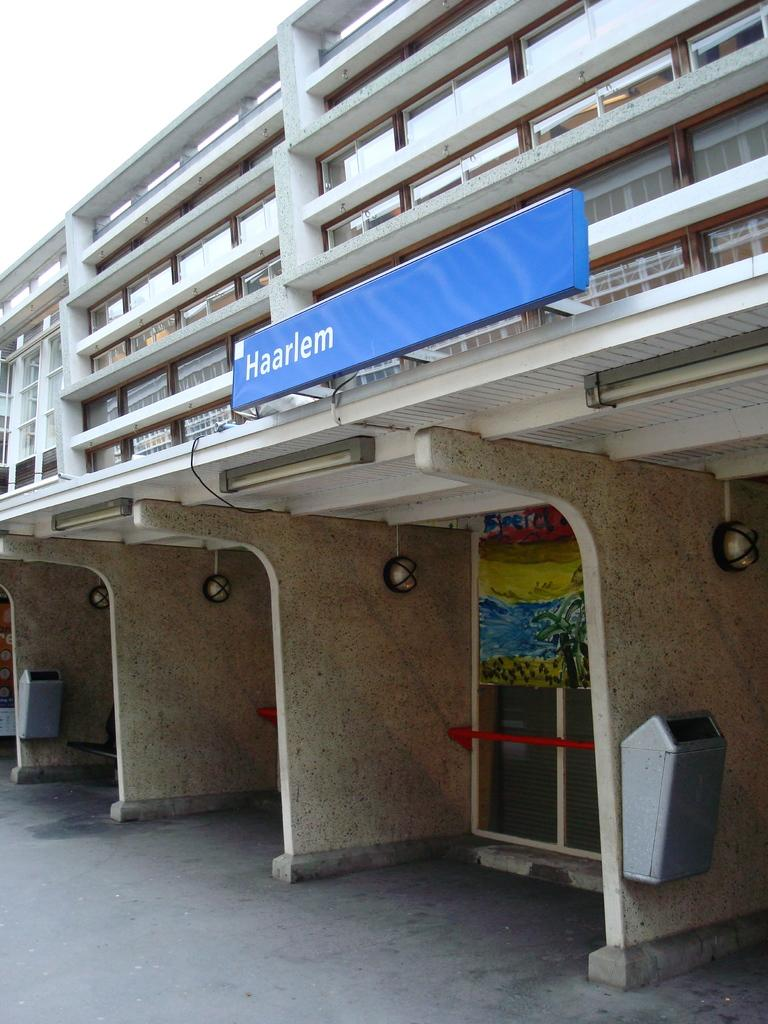What structure is present in the image? There is a building in the image. What is attached to the building? There is a board with text attached to the building. Are there any additional features on the building? Yes, there are lights attached to the building. What can be seen below the building in the image? The ground is visible in the image. What is visible above the building in the image? The sky is visible in the image. How many tomatoes can be seen rolling on the floor in the image? There are no tomatoes or rolling motion present in the image. 